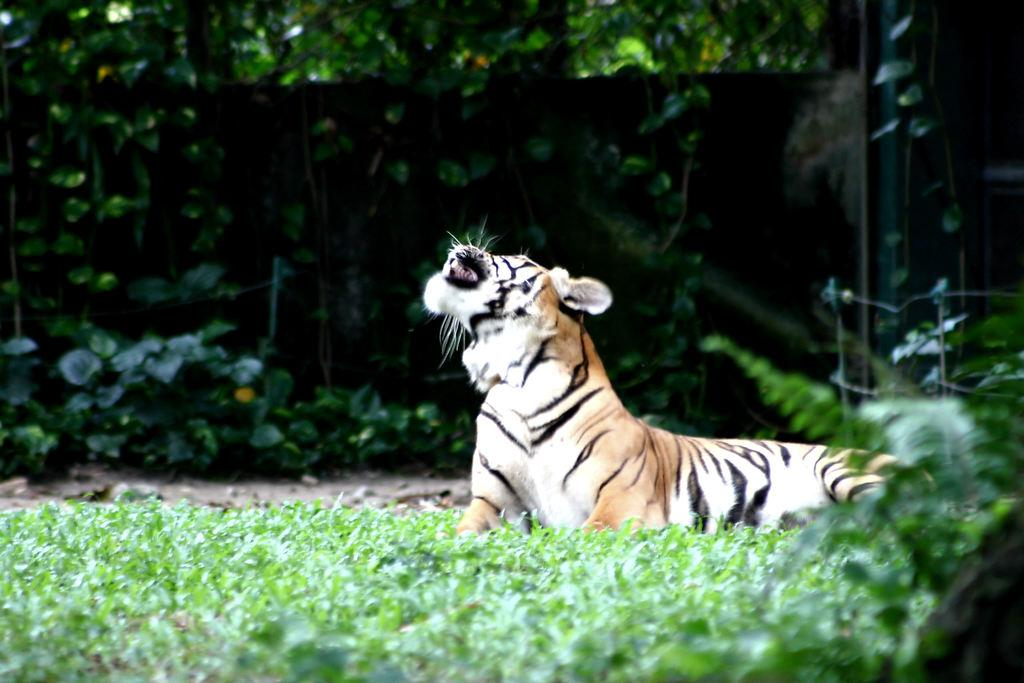What type of animal is in the image? There is a tiger in the image. What is in front of the tiger? There are plants in front of the tiger. What is behind the tiger? There are trees behind the tiger. What can be seen in the background of the image? The image appears to have a wall in the background. How does the crowd interact with the tiger in the image? There is no crowd present in the image; it only features a tiger, plants, trees, and a wall in the background. 